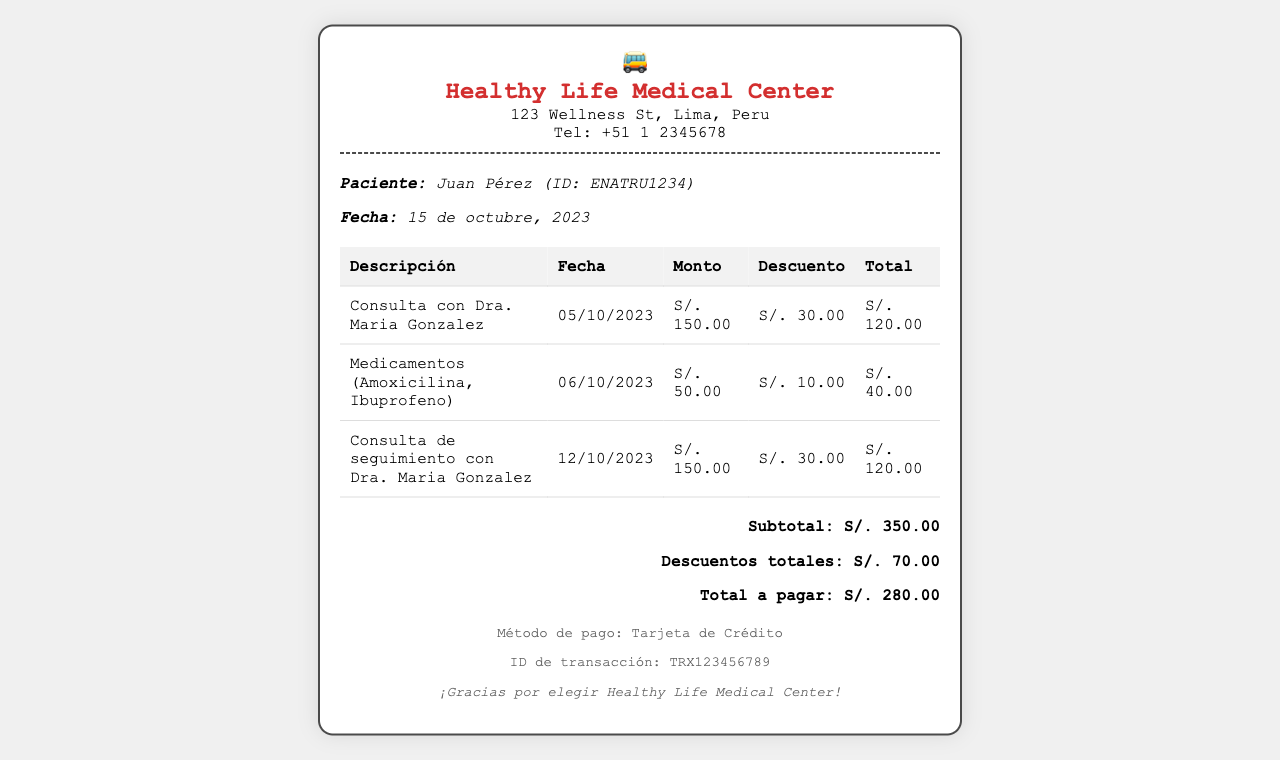¿Qué clínica emitió este recibo? La clínica que emitió el recibo es mencionada en la cabecera del documento.
Answer: Healthy Life Medical Center ¿Cuál es el ID del paciente? El ID del paciente se encuentra bajo el nombre del paciente en el recibo.
Answer: ENATRU1234 ¿Cuánto fue el descuento total aplicado? El descuento total se puede encontrar en la sección de totales del documento.
Answer: S/. 70.00 ¿Cuánto tuvo que pagar el paciente en total? El total a pagar está indicado en la sección de totales.
Answer: S/. 280.00 ¿Qué medicamento fue incluido en la factura? Se puede observar en la tabla de gastos que se detallan los medicamentos.
Answer: Amoxicilina, Ibuprofeno ¿En qué fecha se realizó la primera consulta? La fecha de la primera consulta se muestra junto con la descripción de la misma en el documento.
Answer: 05/10/2023 ¿Qué método de pago se utilizó? El método de pago se menciona en la sección del pie de página del recibo.
Answer: Tarjeta de Crédito ¿Cuál es el monto de la consulta de seguimiento? El monto de la consulta de seguimiento se detalla en la tabla de servicios prestados.
Answer: S/. 150.00 ¿Cuál fue el monto original de los medicamentos? El monto original de los medicamentos se encuentra en la tabla bajo la columna correspondiente.
Answer: S/. 50.00 